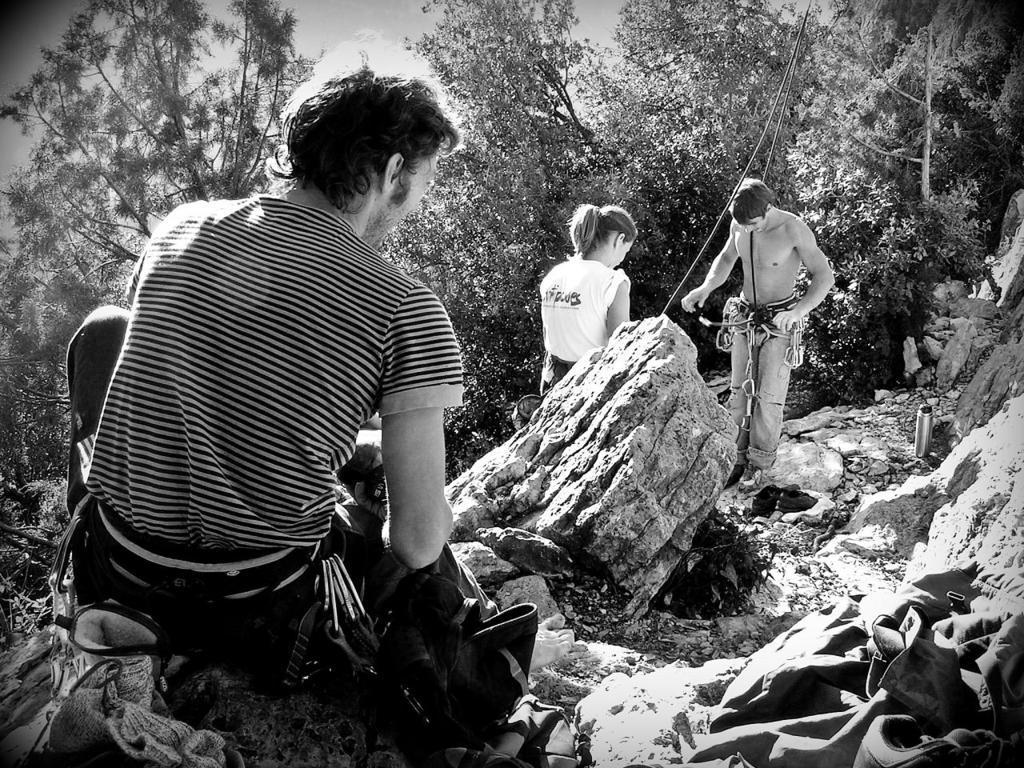Can you describe this image briefly? This is a black and white image, in this image there is a man sitting on a rock and there is a woman and a man standing, in the background there are trees. 